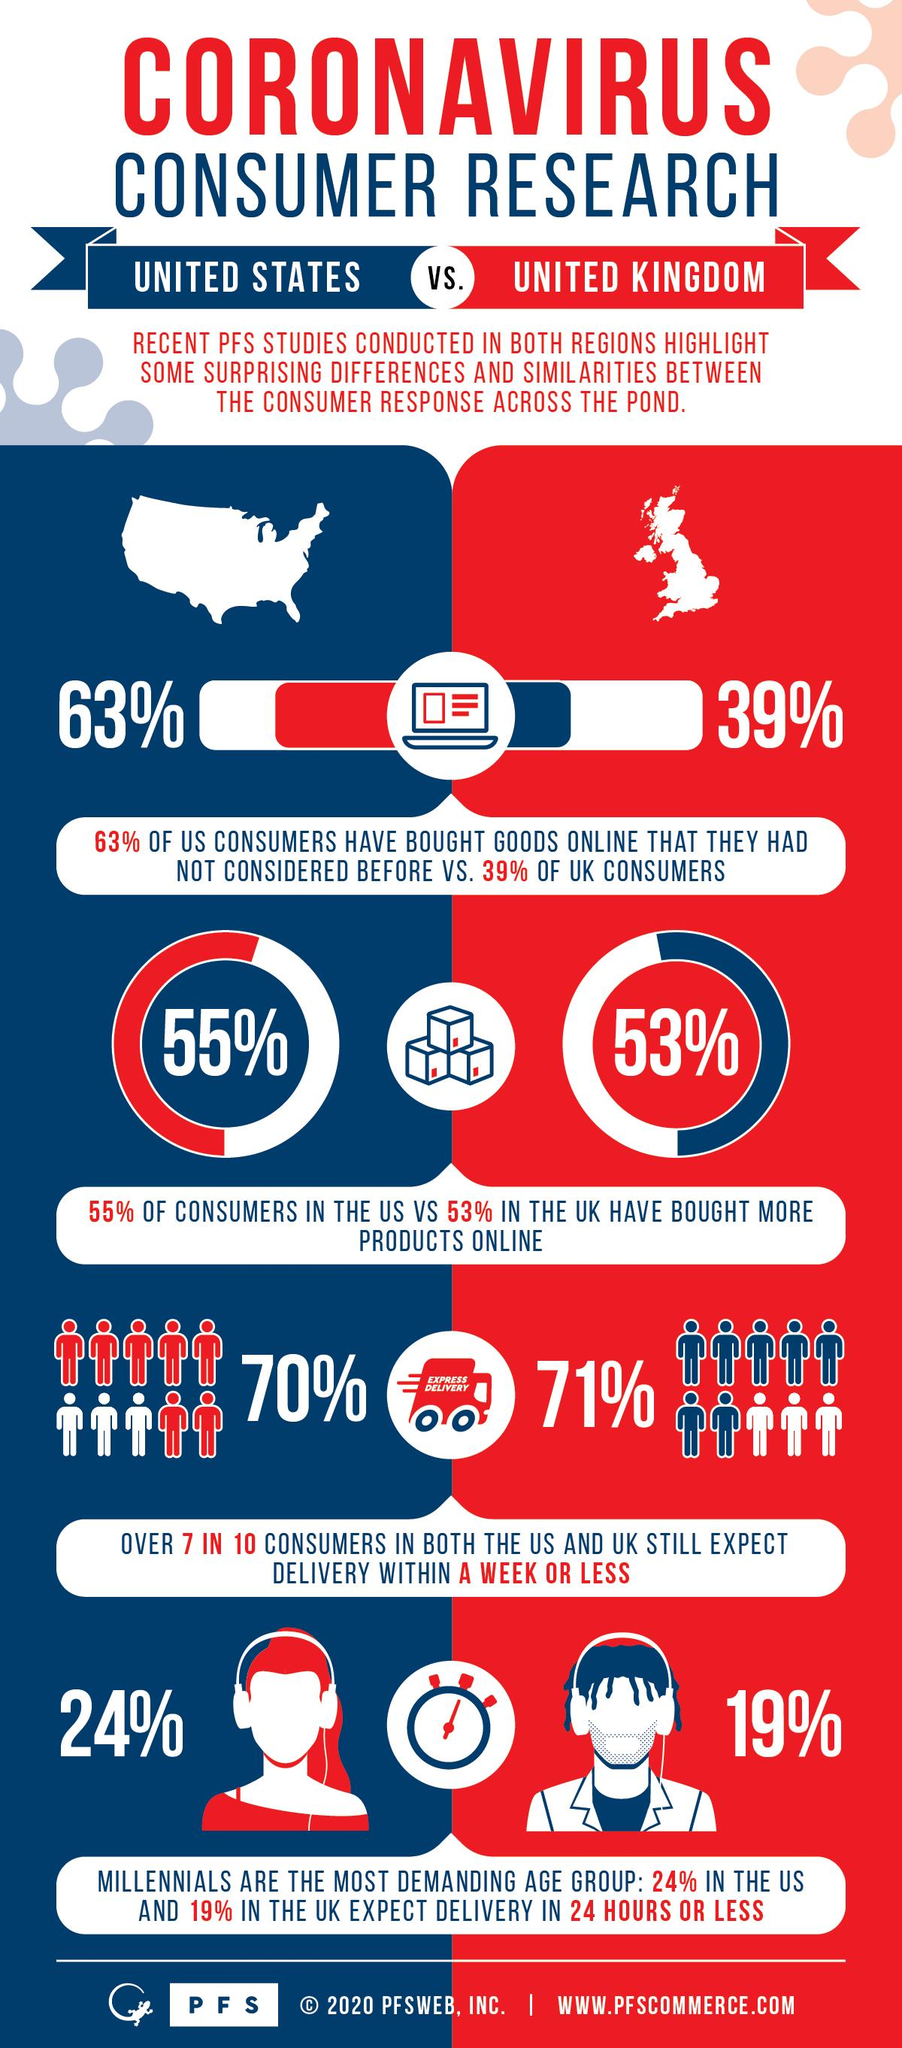Indicate a few pertinent items in this graphic. According to a recent survey, 39% of UK consumers have purchased online goods that they had not previously considered. A majority of 70% of US consumers still expect the delivery of their products within a week or less, indicating a strong emphasis on prompt delivery as a critical aspect of their shopping experience. A significant majority of UK consumers, at 71%, still expect their products to be delivered within a week or less, indicating a strong preference for expedited shipping. A majority of US consumers, at 55%, have purchased additional products online. 